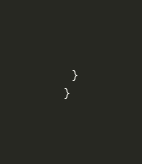Convert code to text. <code><loc_0><loc_0><loc_500><loc_500><_TypeScript_>  }
}
</code> 